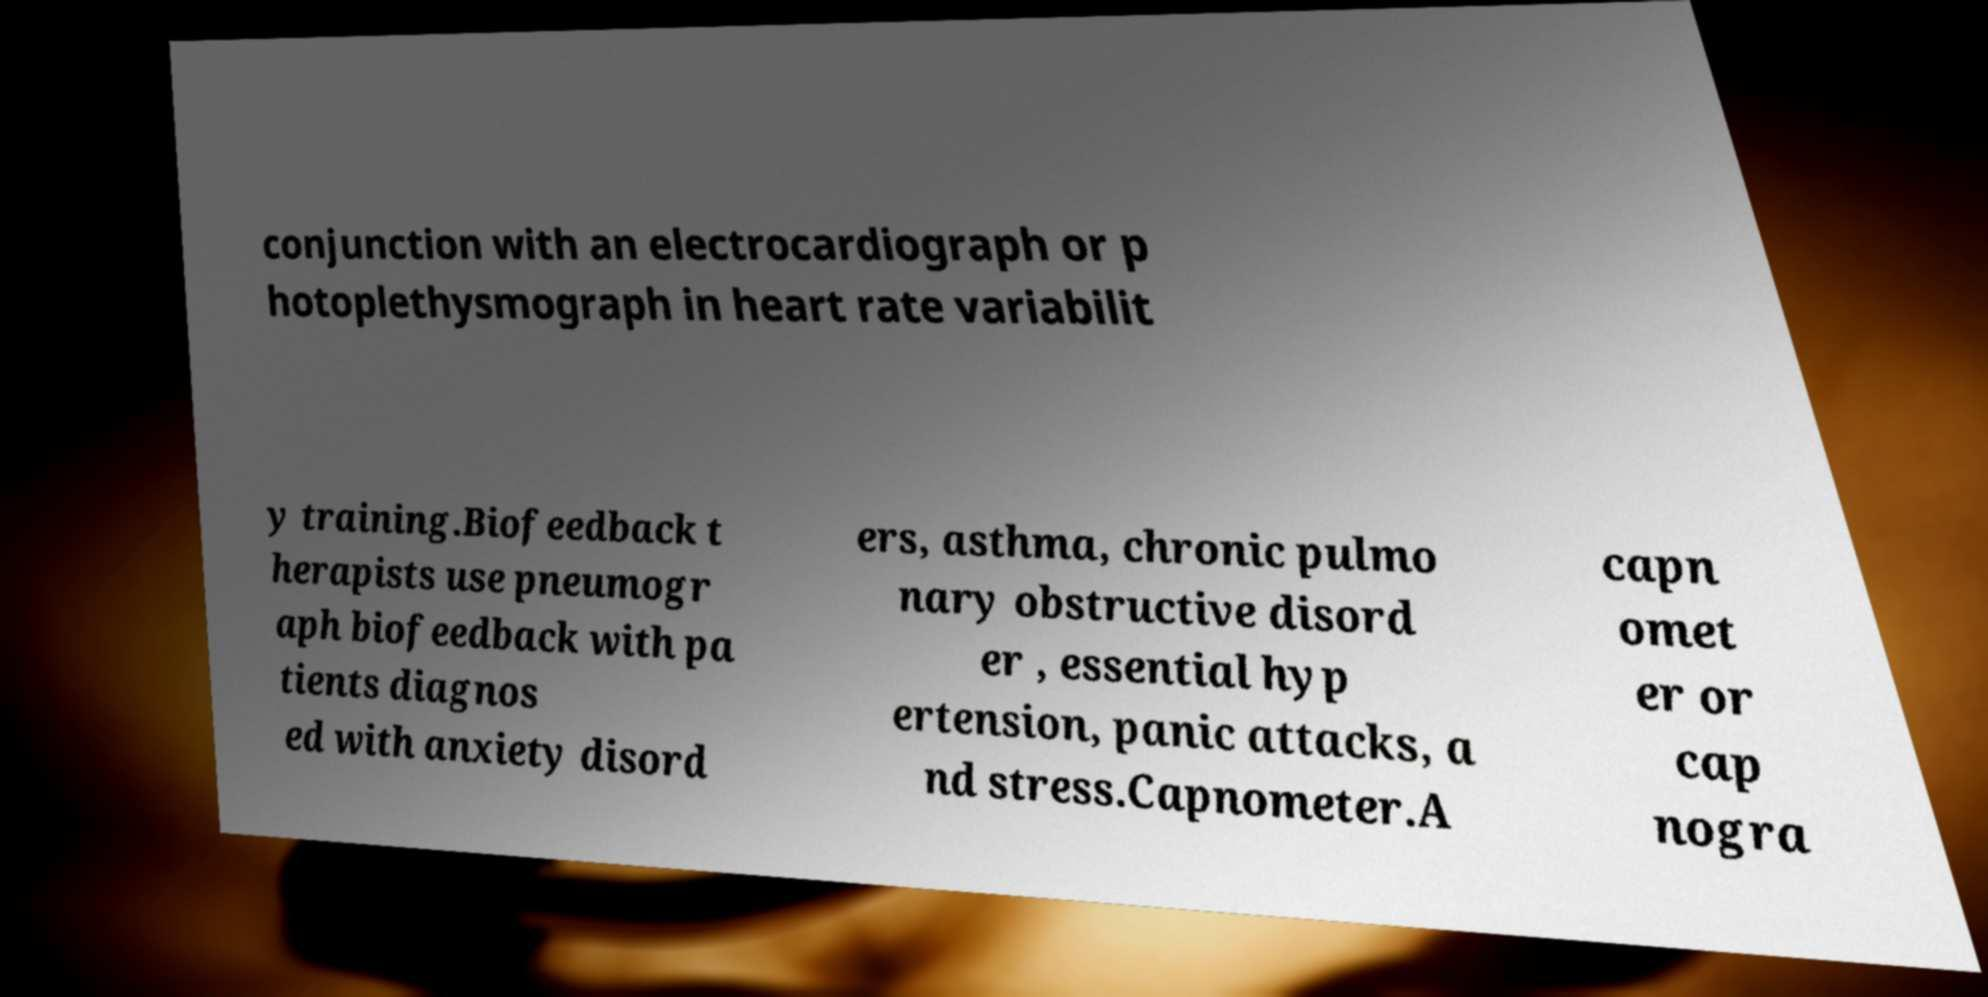Could you extract and type out the text from this image? conjunction with an electrocardiograph or p hotoplethysmograph in heart rate variabilit y training.Biofeedback t herapists use pneumogr aph biofeedback with pa tients diagnos ed with anxiety disord ers, asthma, chronic pulmo nary obstructive disord er , essential hyp ertension, panic attacks, a nd stress.Capnometer.A capn omet er or cap nogra 